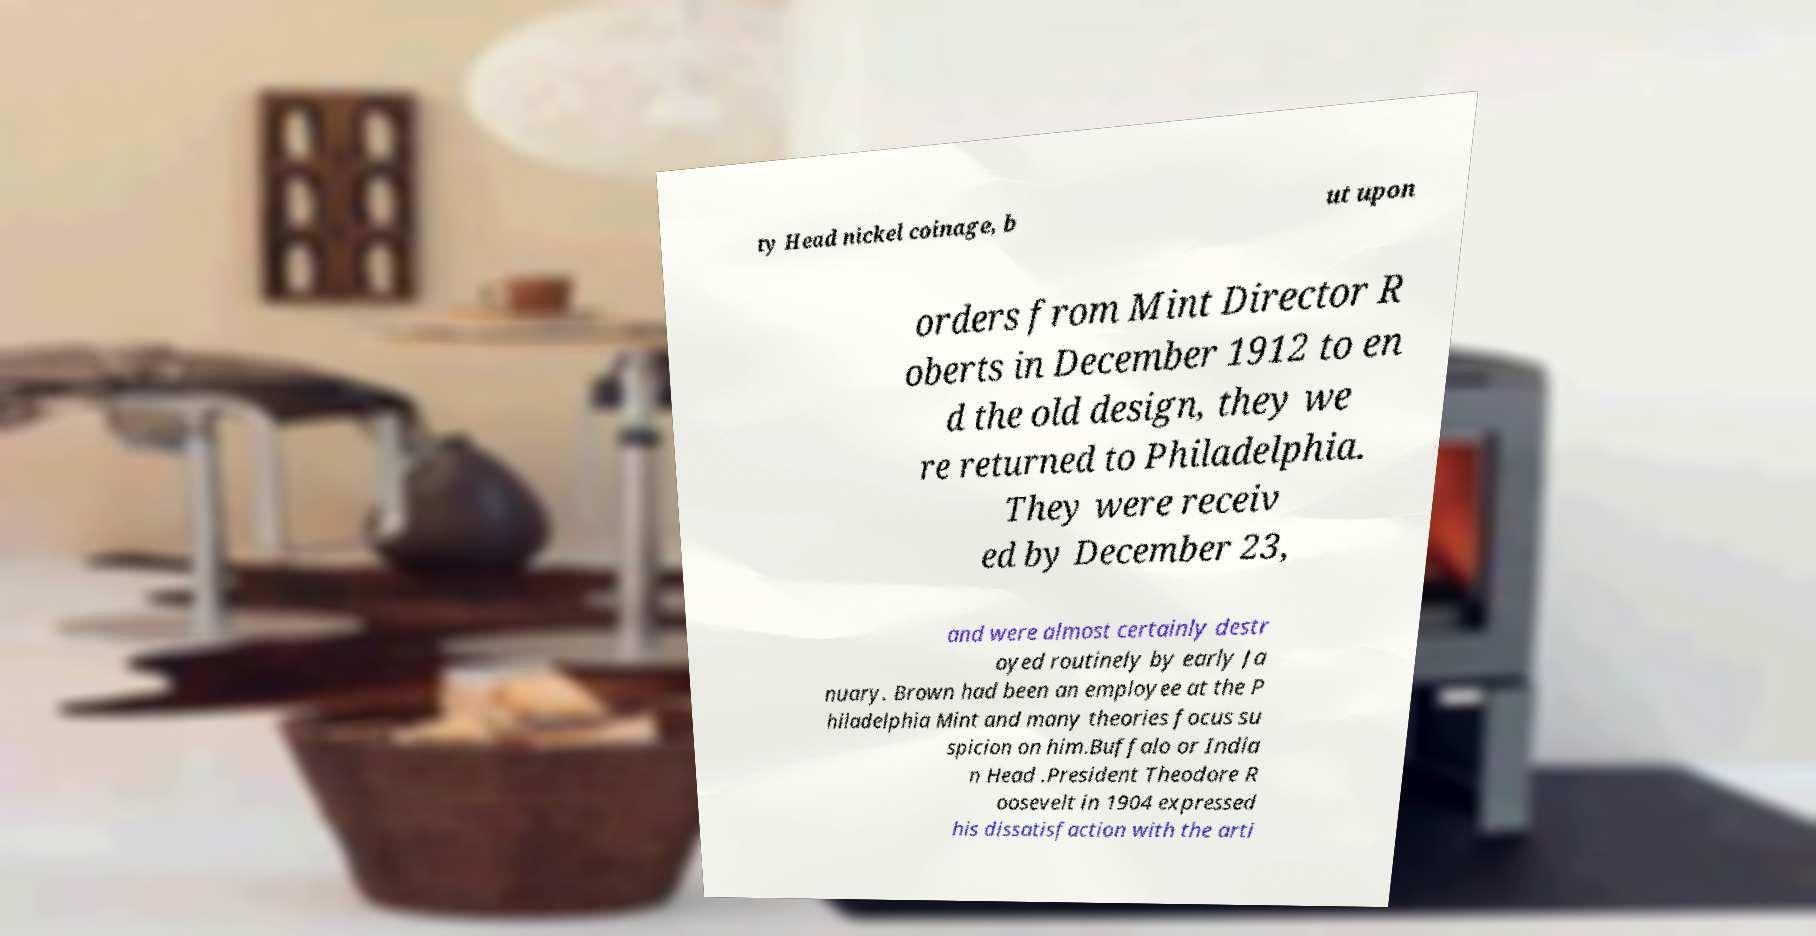Can you read and provide the text displayed in the image?This photo seems to have some interesting text. Can you extract and type it out for me? ty Head nickel coinage, b ut upon orders from Mint Director R oberts in December 1912 to en d the old design, they we re returned to Philadelphia. They were receiv ed by December 23, and were almost certainly destr oyed routinely by early Ja nuary. Brown had been an employee at the P hiladelphia Mint and many theories focus su spicion on him.Buffalo or India n Head .President Theodore R oosevelt in 1904 expressed his dissatisfaction with the arti 